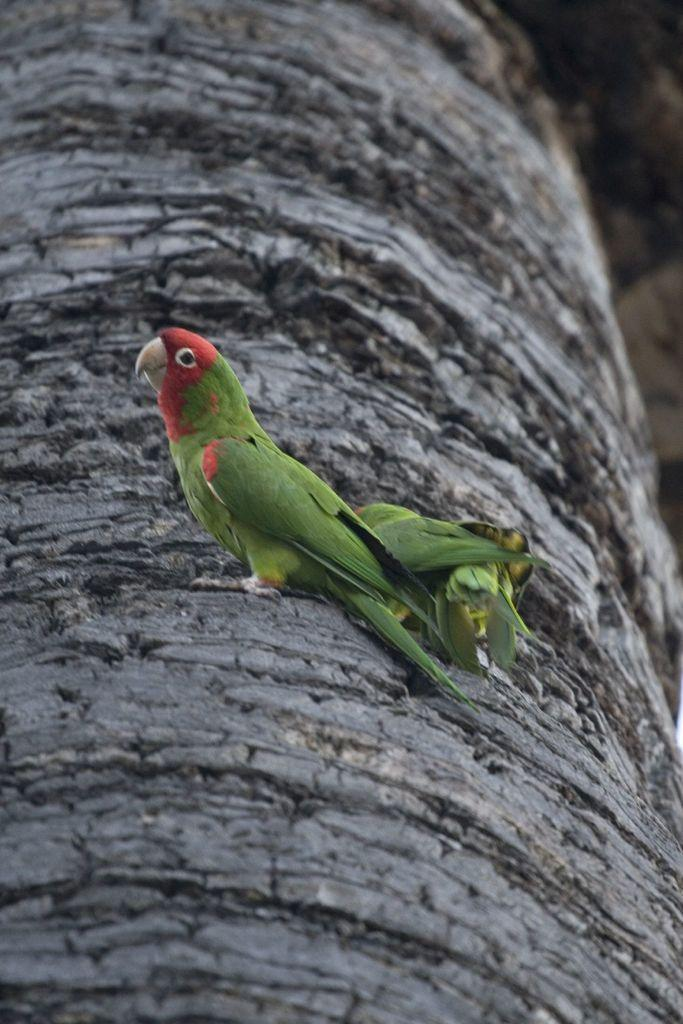What type of animal can be seen in the image? There is a bird in the image. Where is the bird located? The bird is on a tree trunk. What type of calculator is the bird using in the image? There is no calculator present in the image; it features a bird on a tree trunk. What type of drink is the bird holding in the image? There is no drink present in the image; it features a bird on a tree trunk. 